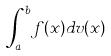<formula> <loc_0><loc_0><loc_500><loc_500>\int _ { a } ^ { b } f ( x ) d v ( x )</formula> 